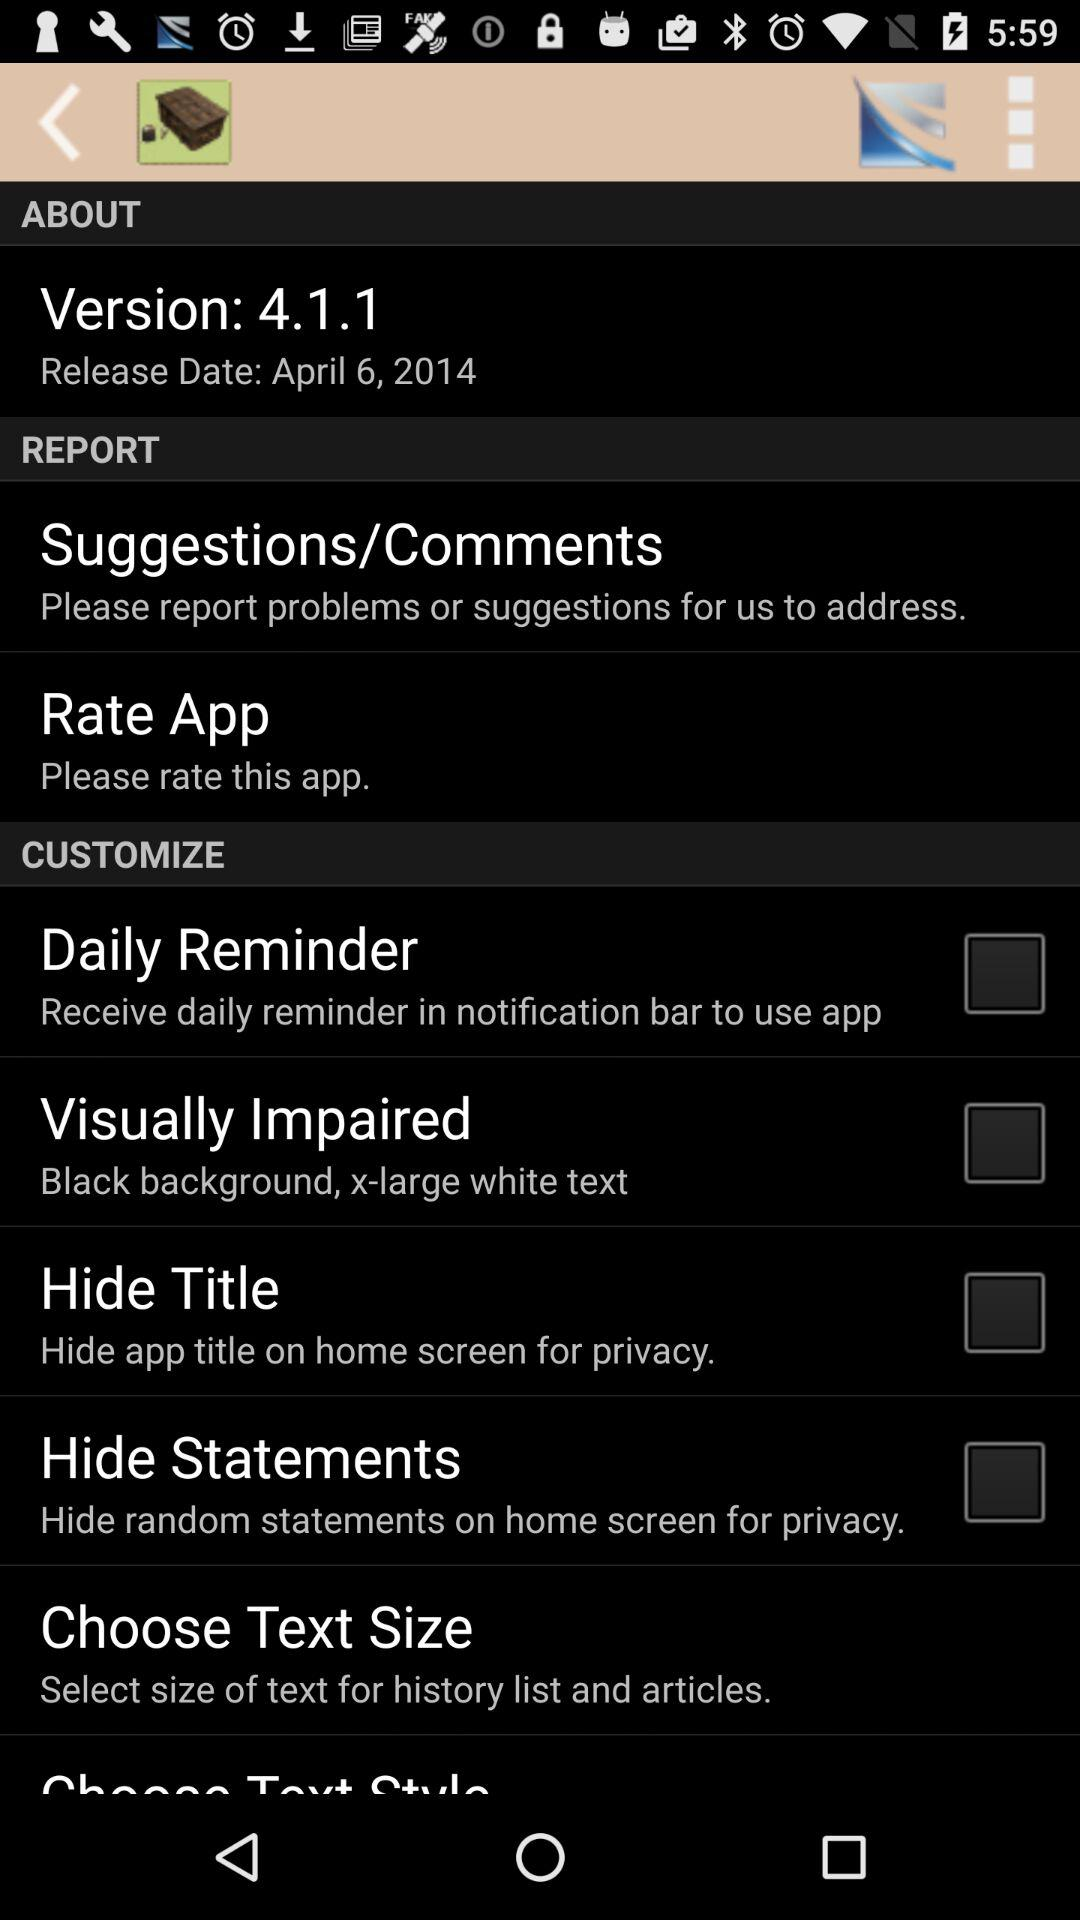What is the status of "Hide Title"? The status is "off". 